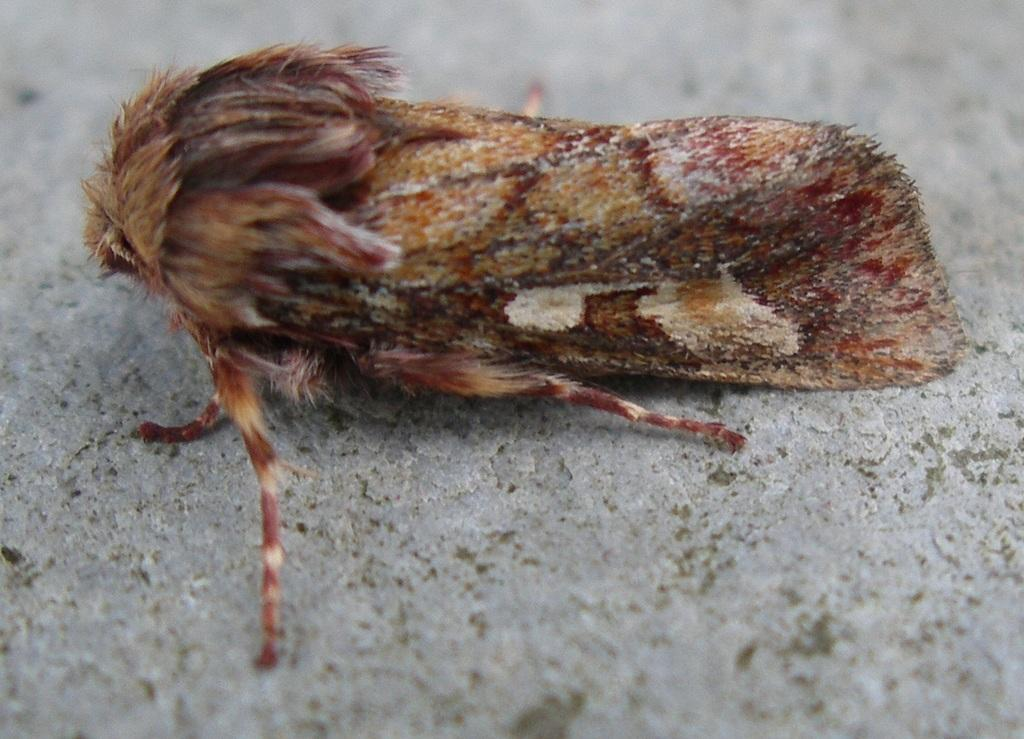What type of creature is present in the image? There is an insect in the image. Can you describe the color of the insect? The insect is white and light brown in color. What surface is visible in the image? The image shows a floor. What type of curtain can be seen hanging from the edge of the image? There is no curtain present in the image; it only shows an insect on a floor. 